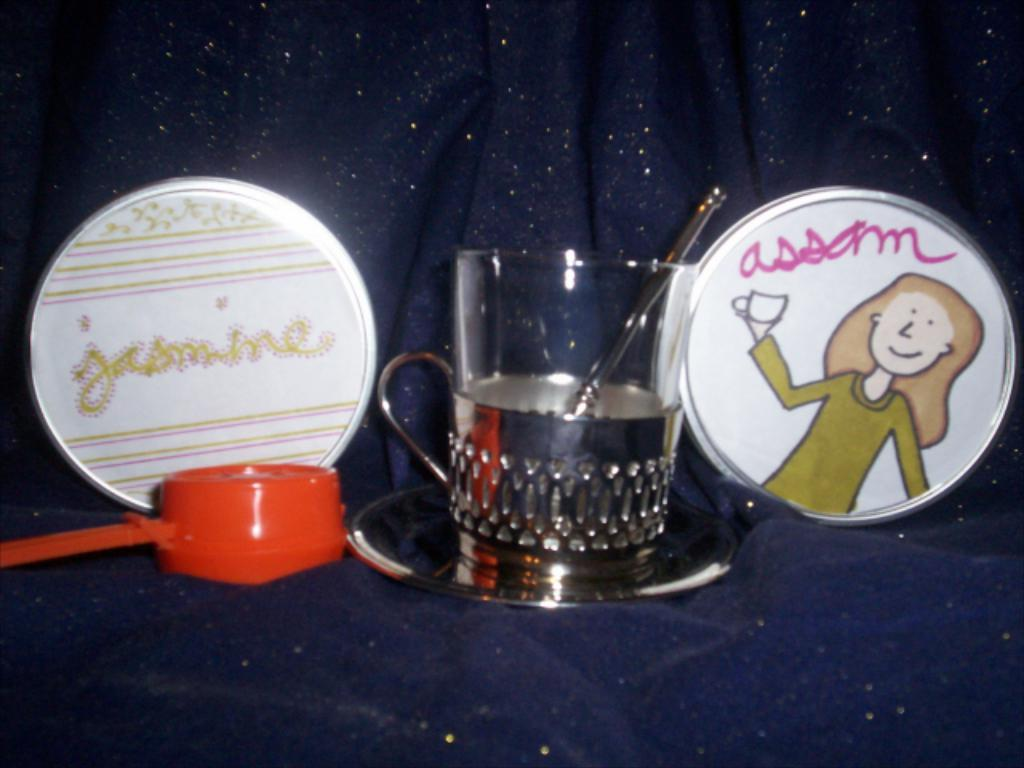What piece of furniture is located at the bottom of the image? There is a couch at the bottom of the image. What objects are in the middle of the image? There is a saucer and a cup in the middle of the image. What else can be seen on the couch? There are additional items on the couch. Where is the shop located in the image? There is no shop present in the image. What type of nut is visible on the couch? There is no nut visible in the image. 